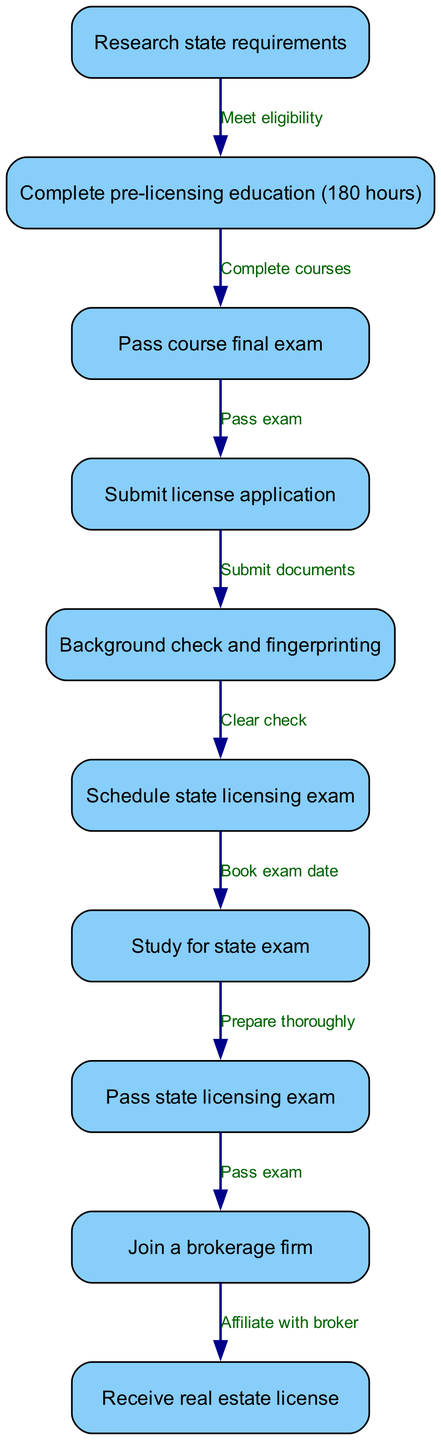What is the first step in obtaining a real estate license? The first node in the diagram outlines the initial action required, which is to research state requirements. This is indicated as node 1 in the flowchart.
Answer: Research state requirements How many hours of pre-licensing education are required? Node 2 specifies that completing 180 hours of pre-licensing education is necessary. This information is clearly stated in the diagram.
Answer: 180 hours What must you pass after completing pre-licensing education? After completing the education, the next step in the flow is node 3, which indicates that one must pass the course final exam. This is a clear sequential requirement in the diagram.
Answer: Pass course final exam What action follows submitting the license application? According to the diagram, after submitting the license application as shown in node 4, the next step listed is to undergo a background check and fingerprinting, indicated in node 5. This follows directly from submitting the application.
Answer: Background check and fingerprinting What do you need to clear before scheduling the state licensing exam? In the flowchart, after the background check and fingerprinting in node 5, it states that you must clear the background check to proceed to schedule the state licensing exam in node 6. This indicates a dependency in the process.
Answer: Clear check How does passing the state licensing exam relate to joining a brokerage firm? The diagram shows that after passing the state licensing exam in node 8, the next step is to join a brokerage firm at node 9. This indicates the sequence in which these actions must happen, linking the two together in the process.
Answer: Pass exam What is the total number of nodes in the diagram? By counting the number of unique steps depicted in the diagram, we find there are 10 nodes representing distinct tasks in the licensing process.
Answer: 10 What is the relationship between the course final exam and the license application? The relationship is that one must first pass the course final exam (node 3) before being able to submit the license application (node 4). This reflects a sequential requirement in the licensing process.
Answer: Pass exam Which step comes directly after studying for the state exam? Following the study preparation for the state exam in node 7, the next required action is to pass the state licensing exam as indicated in node 8. This is clearly documented in the flowchart.
Answer: Pass state licensing exam 